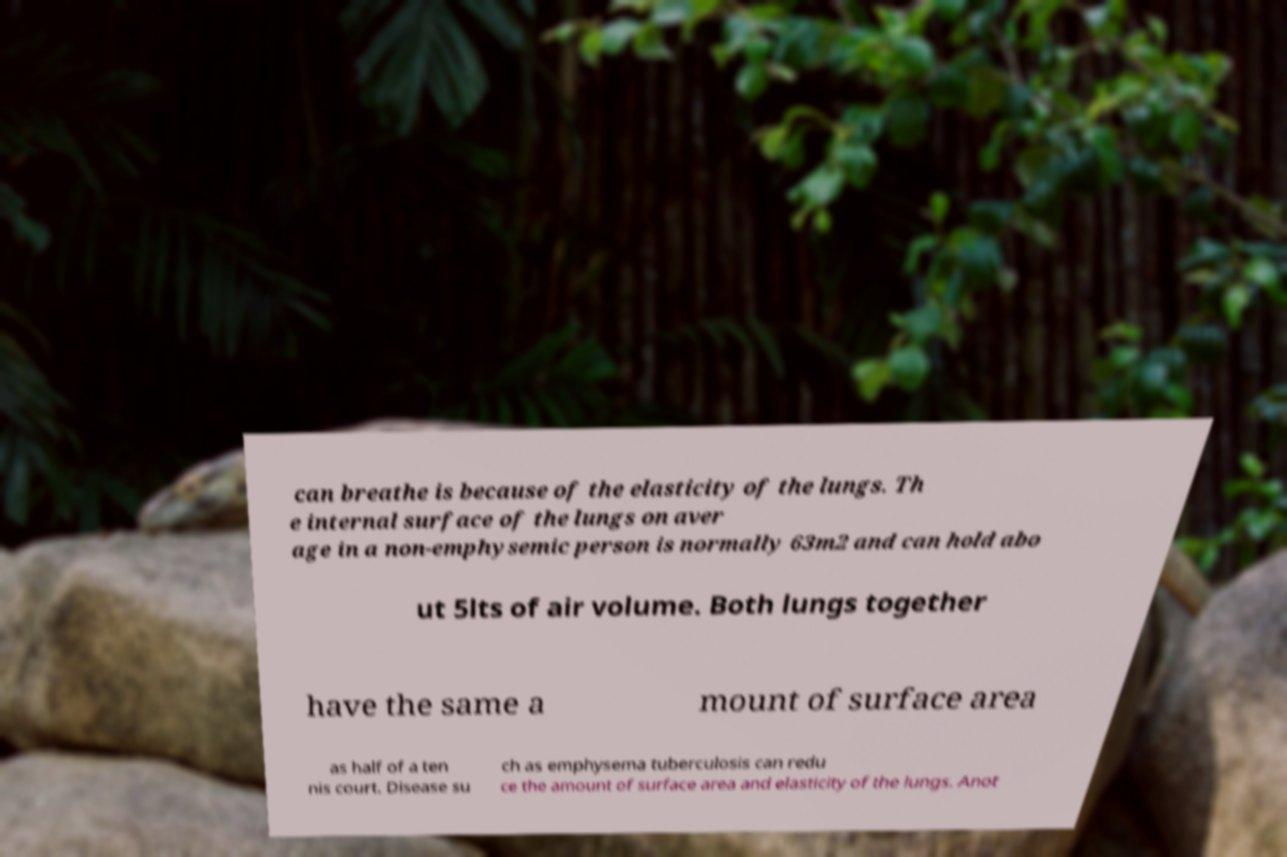Can you read and provide the text displayed in the image?This photo seems to have some interesting text. Can you extract and type it out for me? can breathe is because of the elasticity of the lungs. Th e internal surface of the lungs on aver age in a non-emphysemic person is normally 63m2 and can hold abo ut 5lts of air volume. Both lungs together have the same a mount of surface area as half of a ten nis court. Disease su ch as emphysema tuberculosis can redu ce the amount of surface area and elasticity of the lungs. Anot 